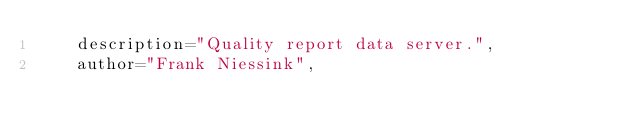<code> <loc_0><loc_0><loc_500><loc_500><_Python_>    description="Quality report data server.",
    author="Frank Niessink",</code> 